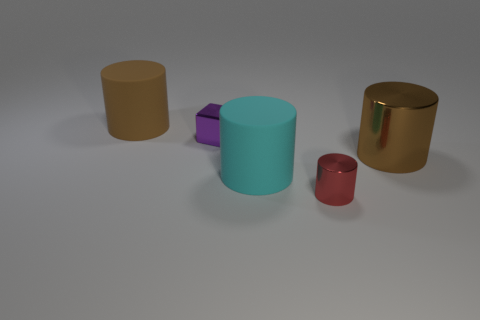How many other cylinders have the same color as the large metallic cylinder?
Your answer should be very brief. 1. Are there fewer red cylinders than metallic cylinders?
Provide a short and direct response. Yes. Do the block and the big cyan cylinder have the same material?
Your answer should be compact. No. What number of other objects are the same size as the cyan rubber cylinder?
Provide a succinct answer. 2. There is a big matte object in front of the brown object that is left of the tiny red metallic cylinder; what is its color?
Your answer should be compact. Cyan. What number of other things are there of the same shape as the brown matte thing?
Ensure brevity in your answer.  3. Is there a small red cylinder that has the same material as the small purple thing?
Your answer should be compact. Yes. There is a brown cylinder that is the same size as the brown rubber object; what material is it?
Ensure brevity in your answer.  Metal. What color is the big cylinder in front of the big brown cylinder that is right of the big brown thing to the left of the large cyan matte cylinder?
Provide a succinct answer. Cyan. There is a tiny object that is to the left of the cyan object; does it have the same shape as the large brown object that is on the right side of the tiny red cylinder?
Give a very brief answer. No. 